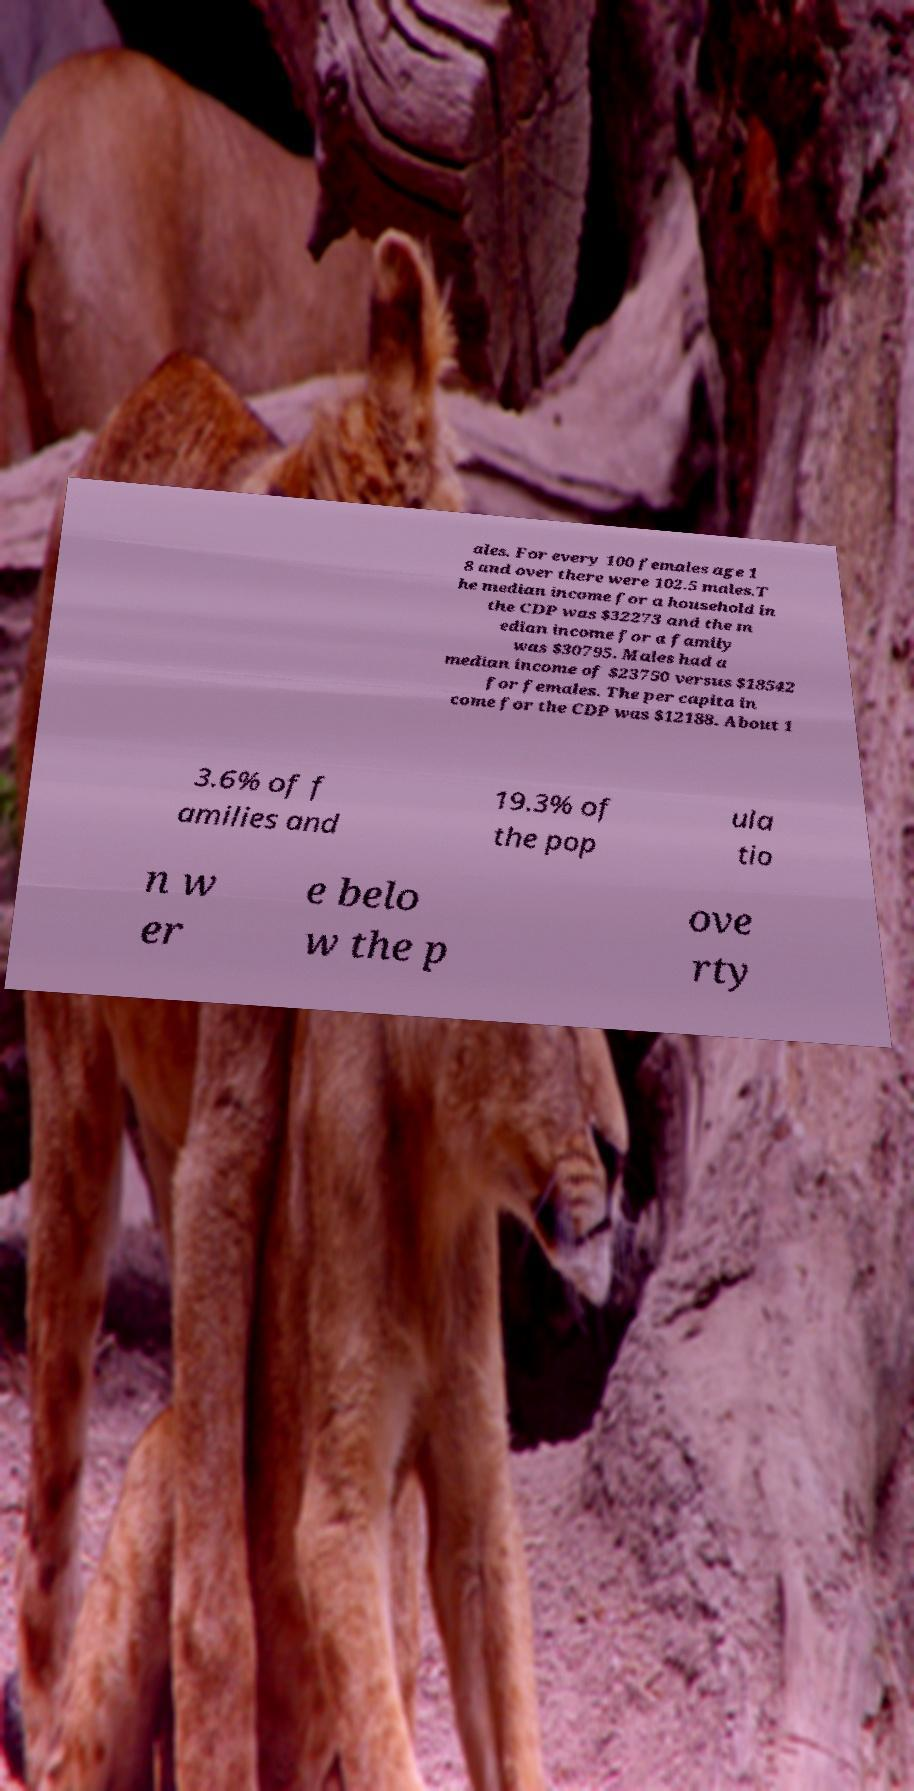Can you accurately transcribe the text from the provided image for me? ales. For every 100 females age 1 8 and over there were 102.5 males.T he median income for a household in the CDP was $32273 and the m edian income for a family was $30795. Males had a median income of $23750 versus $18542 for females. The per capita in come for the CDP was $12188. About 1 3.6% of f amilies and 19.3% of the pop ula tio n w er e belo w the p ove rty 